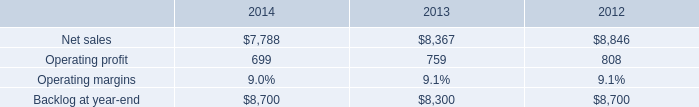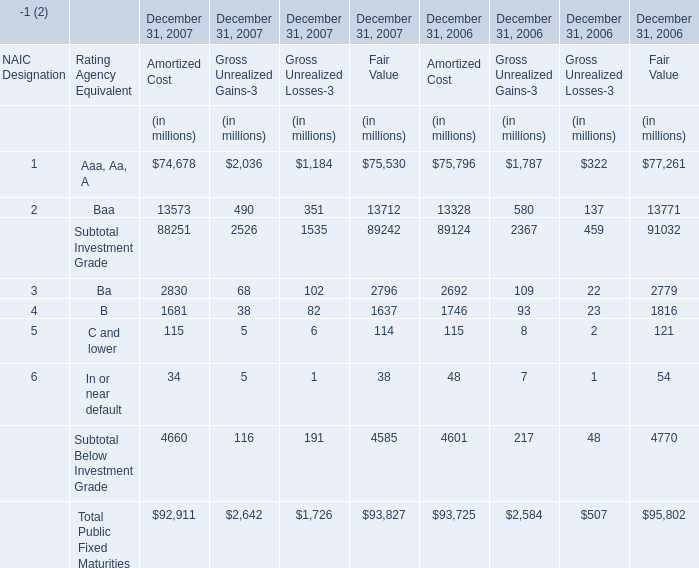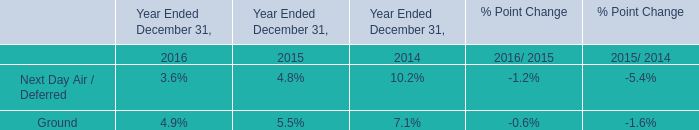Which year is the Fair Value for Rating Agency Equivalent Ba on December 31 the highest? 
Answer: 2007. 